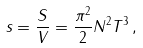<formula> <loc_0><loc_0><loc_500><loc_500>s = \frac { S } { V } = \frac { \pi ^ { 2 } } 2 N ^ { 2 } T ^ { 3 } \, ,</formula> 